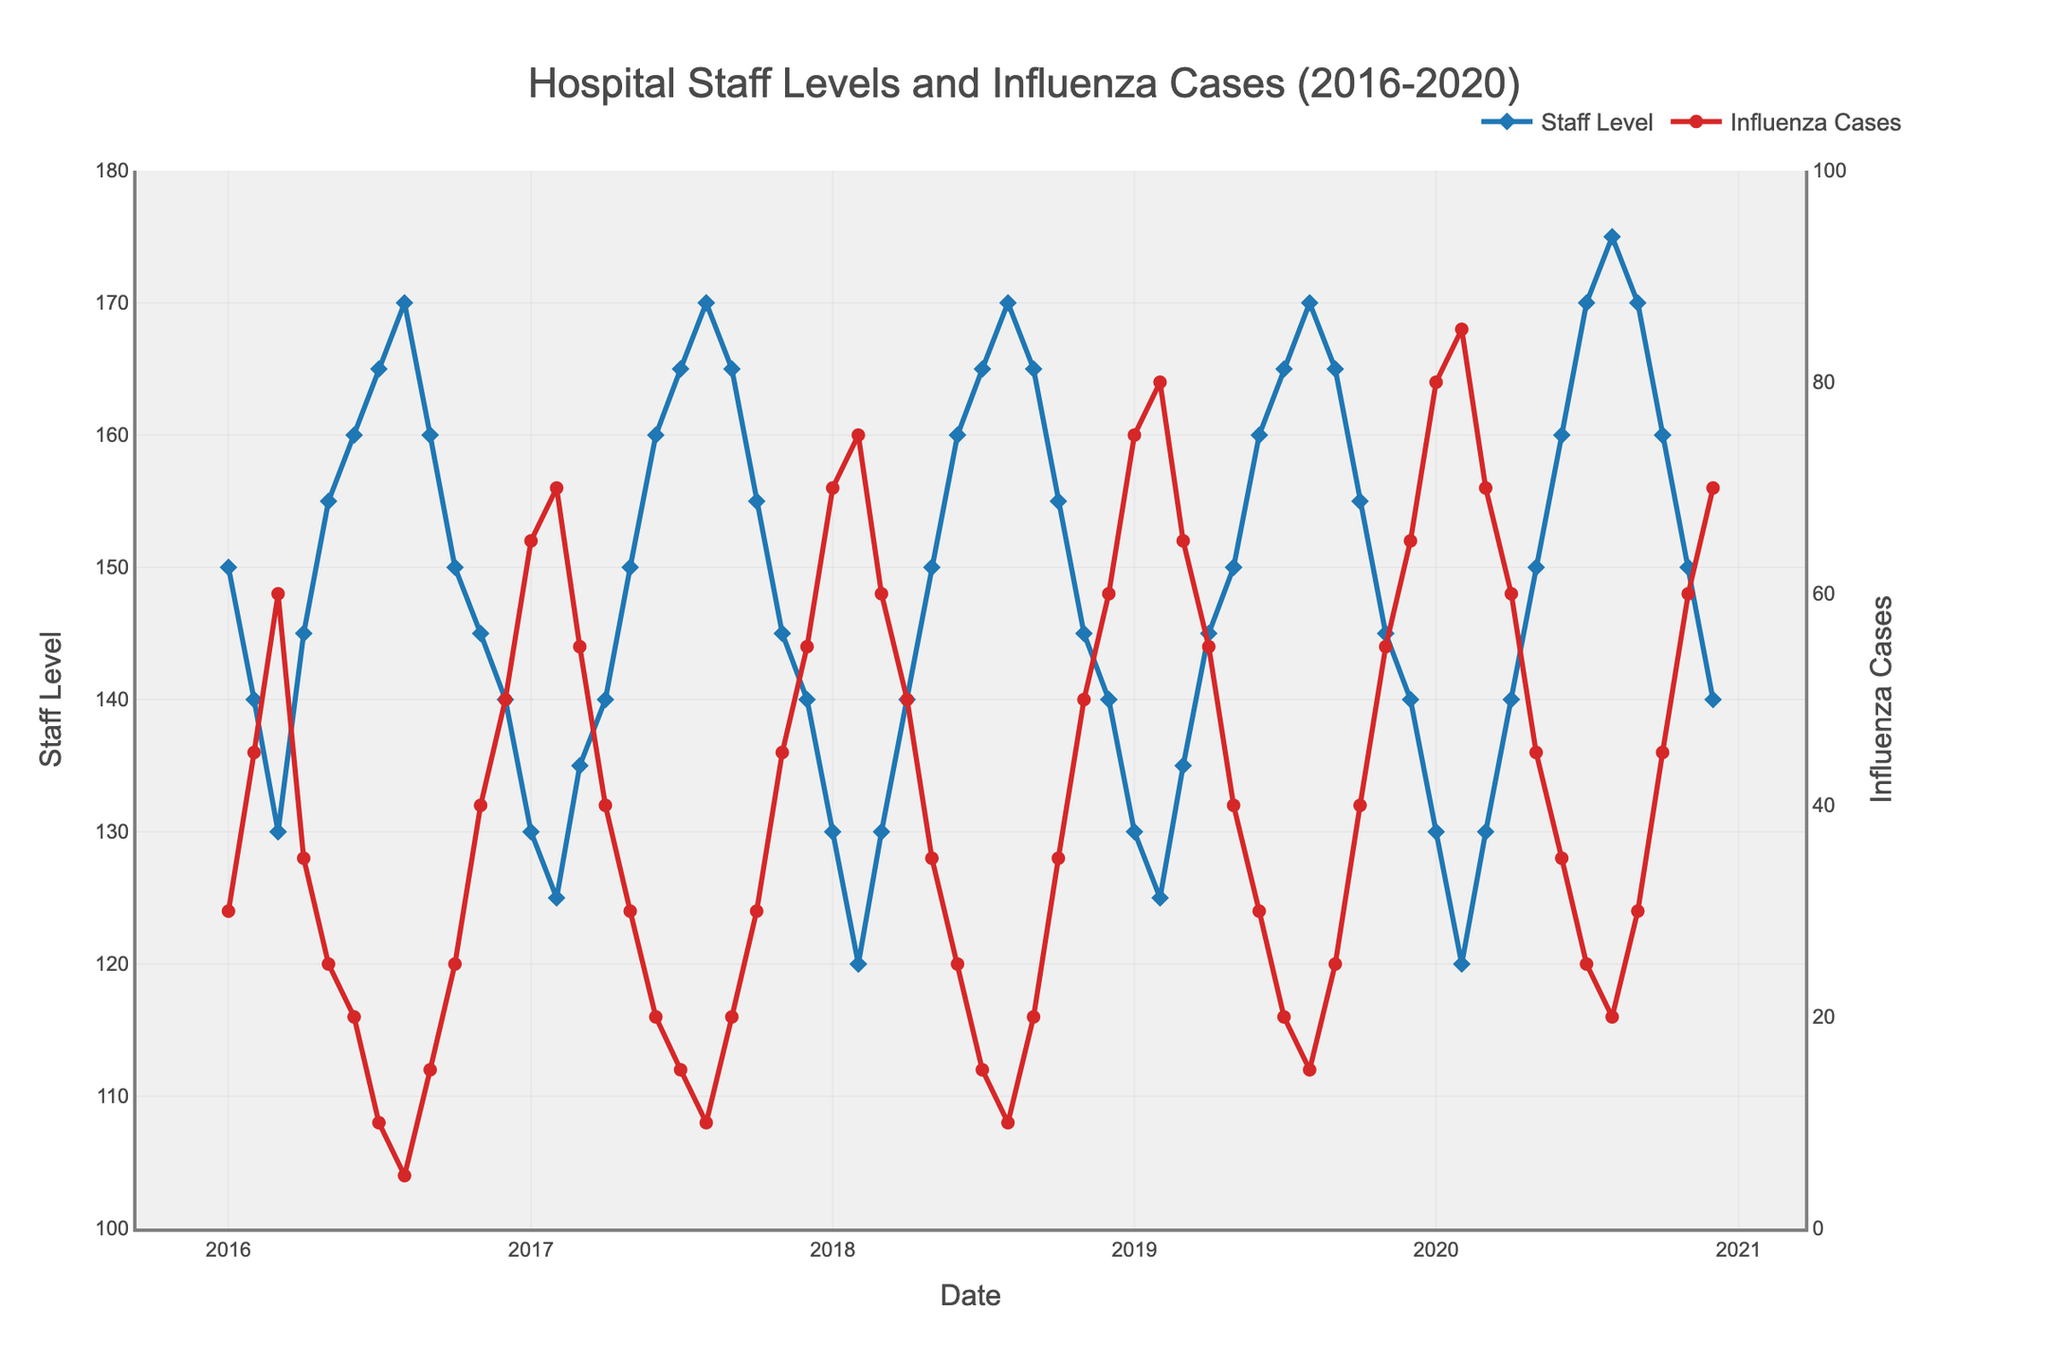What is the title of the figure? The title is displayed at the top of the figure and provides a summary of what the figure is about.
Answer: Hospital Staff Levels and Influenza Cases (2016-2020) What are the colors of the lines representing Staff Level and Influenza Cases? The lines are distinctively colored to differentiate between the two metrics.
Answer: Blue for Staff Level, Red for Influenza Cases How does the Staff Level trend change during influenza peak months? By observing the date axis and comparing it to the fluctuations in Staff Level, we can see patterns during peak influenza months. During months with high influenza cases, Staff Levels generally decrease.
Answer: Typically decreases When do we observe the highest number of influenza cases? Identify the peak by looking at the highest point of the red line representing influenza cases.
Answer: February 2020 Which year shows the minimum Staff Level, and during which month? By looking at the lowest point of the blue line and noting the corresponding date, we identify when the lowest Staff Level occurred.
Answer: February 2020 What is the difference between the highest and lowest Staff Level observed from 2016 to 2020? Check the y-axis for Staff Level, find the minimum and maximum points, and calculate the difference between these values.
Answer: 55 (175 - 120) How does the hospitalization trend compare in terms of Staff Levels between 2016 and 2020 at the beginning of the year (January)? Compare the Staff Levels data points for January of 2016 and 2020.
Answer: Decreased from 150 to 130 What is the average number of influenza cases in December over the years 2016-2020? Sum the influenza cases for each December and then divide by the number of December records.
Answer: 58 ((50 + 55 + 60 + 65 + 70) / 5) Is there a general trend observable in both Staff Levels and Influenza Cases over the years represented? Examine the overall direction or pattern of the lines for both metrics. Staff Levels generally tend to decrease and Influenza Cases tend to increase towards winter months.
Answer: Staff Levels generally decrease and Influenza Cases increase 